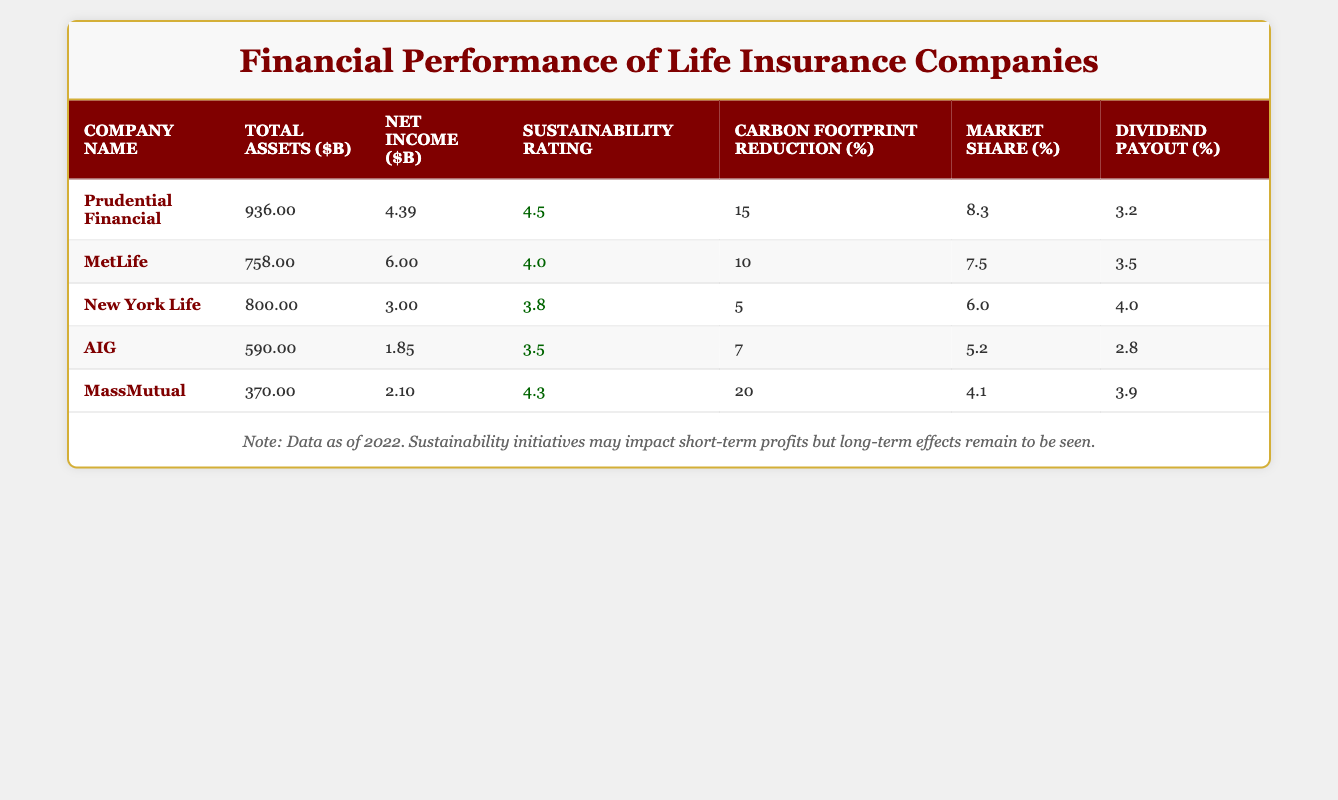What is the total net income of all life insurance companies listed? To find the total net income, we need to sum the net income values of all companies: (4.39 + 6.00 + 3.00 + 1.85 + 2.10) = 17.34 billion.
Answer: 17.34 billion Which company has the highest total assets? From the table, Prudential Financial has the highest total assets at 936 billion.
Answer: Prudential Financial Is MetLife's sustainability rating higher than AIG's? Yes, MetLife has a sustainability rating of 4.0, while AIG has a rating of 3.5, making MetLife's rating higher.
Answer: Yes What is the average carbon footprint reduction percentage among the companies? We calculate the average by summing the carbon footprint reductions: (15 + 10 + 5 + 7 + 20) = 57. Then divide by the number of companies (5): 57 / 5 = 11.4%.
Answer: 11.4% Which company has the lowest market share? AIG has the lowest market share at 5.2%, compared to the others listed.
Answer: AIG What is the difference in net income between Prudential Financial and New York Life? The net income for Prudential is 4.39 billion and for New York Life is 3.00 billion. The difference is 4.39 - 3.00 = 1.39 billion.
Answer: 1.39 billion Are companies with higher sustainability ratings generally showing higher net incomes? Based on the data, higher sustainability ratings do not consistently correlate with higher net income when comparing values across the table. For instance, New York Life has a lower sustainability rating but is comparable in net income to others.
Answer: No What is the sustainability rating of the company with the largest total assets? Prudential Financial, which has the largest total assets of 936 billion, has a sustainability rating of 4.5.
Answer: 4.5 